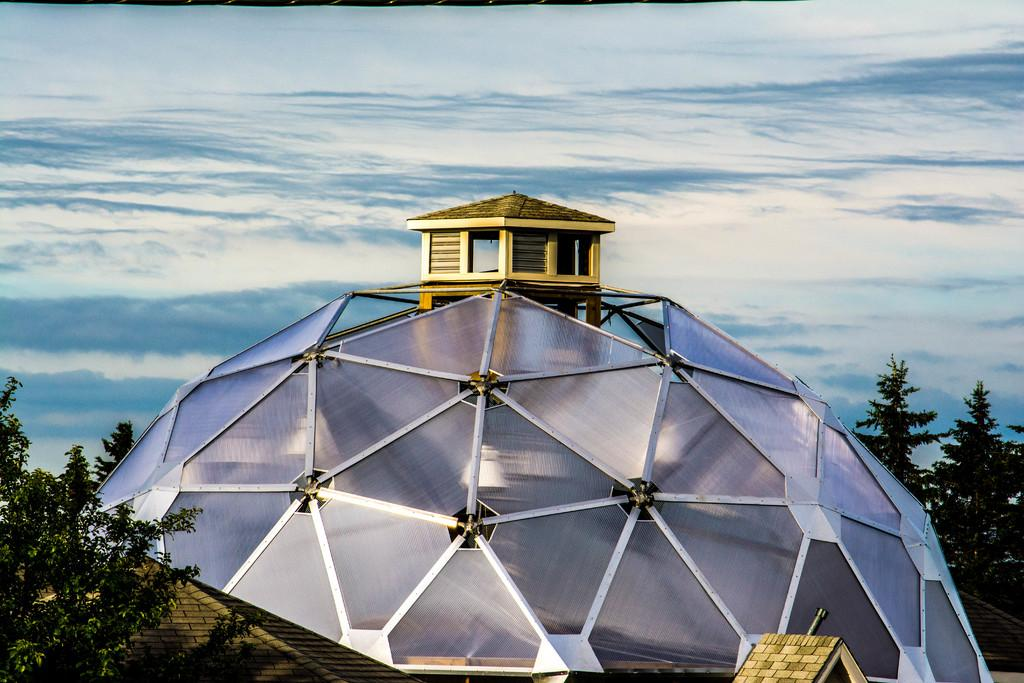What type of structure is visible in the image? There is a building in the image. What can be seen on the left side of the image? There are trees on the left side of the image. What is present on the right side of the image? There are trees on the right side of the image. What is visible in the sky in the background of the image? There are clouds in the sky in the background of the image. Where are the tomatoes growing in the image? There are no tomatoes present in the image. What type of feather can be seen falling from the sky in the image? There is no feather falling from the sky in the image. 